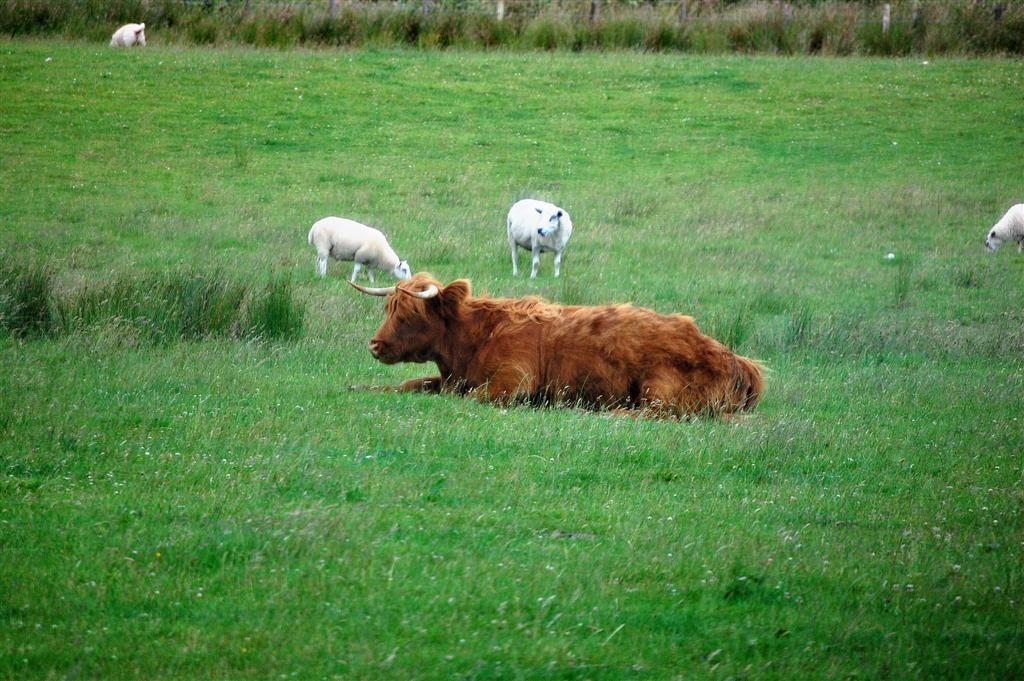What is the main setting of the image? There is an open grass ground in the image. What animals can be seen on the grass ground? There is a brown-colored yak and white-colored sheep on the grass ground. What type of apple is being cooked on the stove in the image? There is no apple or stove present in the image; it features an open grass ground with a yak and sheep. 